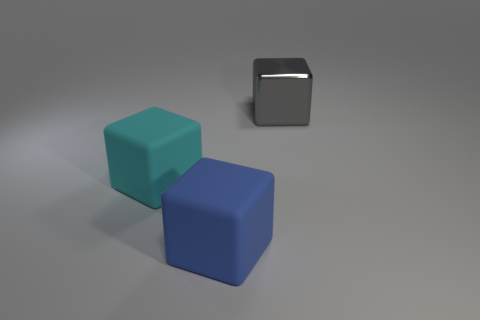Subtract all red blocks. Subtract all cyan spheres. How many blocks are left? 3 Add 2 tiny gray matte things. How many objects exist? 5 Subtract 0 cyan cylinders. How many objects are left? 3 Subtract all big yellow shiny cylinders. Subtract all cyan cubes. How many objects are left? 2 Add 1 big metallic objects. How many big metallic objects are left? 2 Add 2 large matte blocks. How many large matte blocks exist? 4 